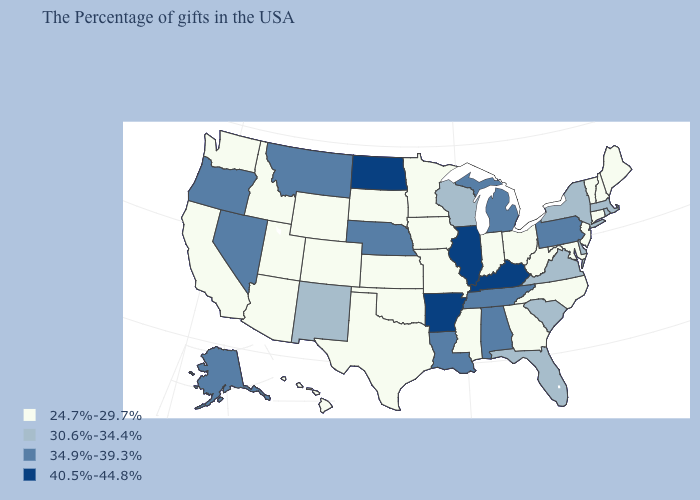What is the highest value in the West ?
Short answer required. 34.9%-39.3%. What is the highest value in the MidWest ?
Answer briefly. 40.5%-44.8%. Which states have the highest value in the USA?
Write a very short answer. Kentucky, Illinois, Arkansas, North Dakota. Which states hav the highest value in the Northeast?
Keep it brief. Pennsylvania. Name the states that have a value in the range 40.5%-44.8%?
Write a very short answer. Kentucky, Illinois, Arkansas, North Dakota. Is the legend a continuous bar?
Quick response, please. No. Does the first symbol in the legend represent the smallest category?
Concise answer only. Yes. Does the first symbol in the legend represent the smallest category?
Short answer required. Yes. Among the states that border Minnesota , which have the highest value?
Concise answer only. North Dakota. Name the states that have a value in the range 24.7%-29.7%?
Keep it brief. Maine, New Hampshire, Vermont, Connecticut, New Jersey, Maryland, North Carolina, West Virginia, Ohio, Georgia, Indiana, Mississippi, Missouri, Minnesota, Iowa, Kansas, Oklahoma, Texas, South Dakota, Wyoming, Colorado, Utah, Arizona, Idaho, California, Washington, Hawaii. What is the highest value in the USA?
Short answer required. 40.5%-44.8%. Which states have the lowest value in the MidWest?
Concise answer only. Ohio, Indiana, Missouri, Minnesota, Iowa, Kansas, South Dakota. What is the value of Georgia?
Short answer required. 24.7%-29.7%. What is the lowest value in states that border Minnesota?
Quick response, please. 24.7%-29.7%. What is the lowest value in the South?
Answer briefly. 24.7%-29.7%. 